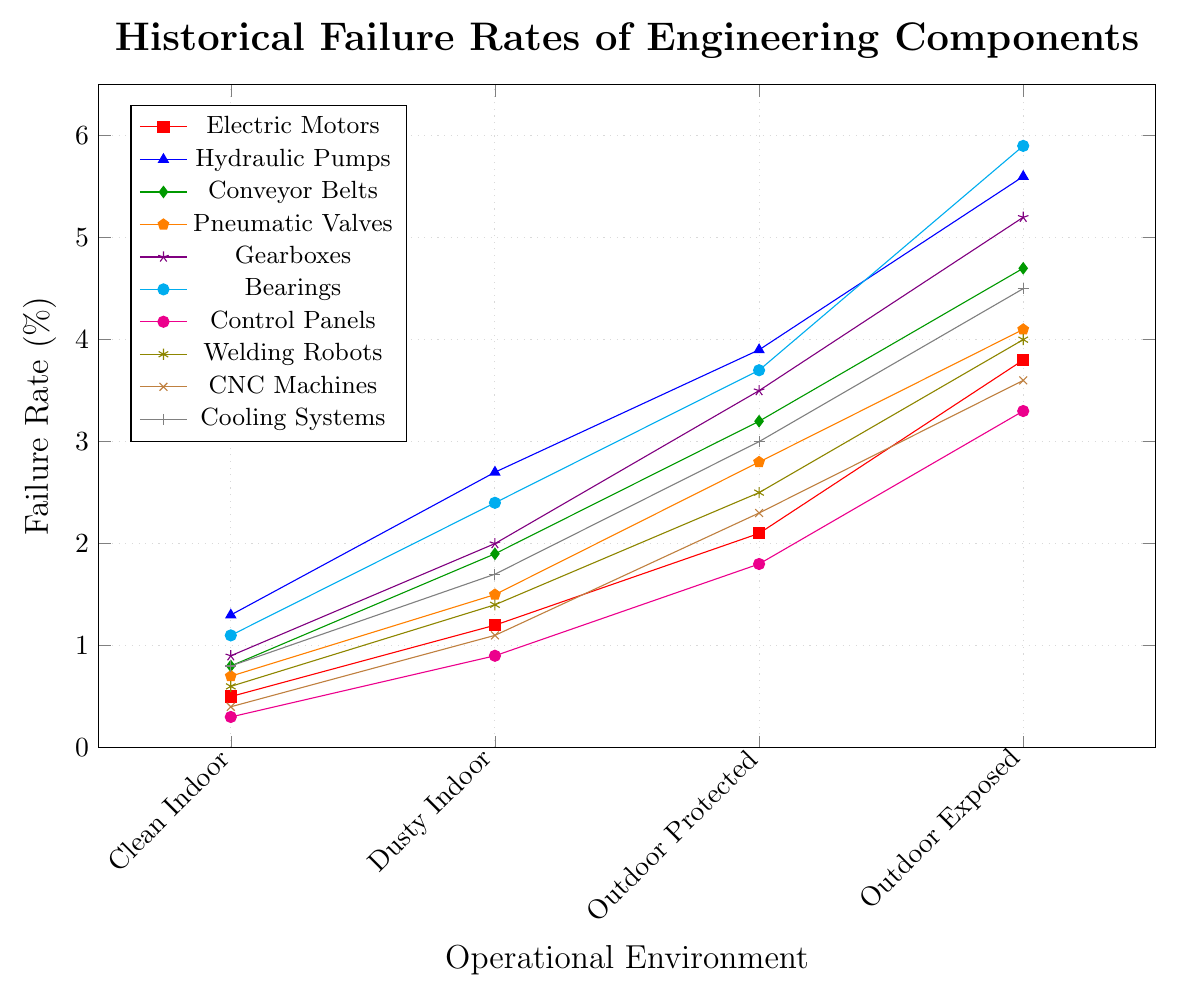Which component has the highest failure rate in the Outdoor Exposed environment? The highest failure rate in the Outdoor Exposed environment corresponds to the highest point on the graph for that condition, which is the Bearings at 5.9%.
Answer: Bearings Which component shows the lowest failure rate across all environments? To determine this, look for the lowest point across all environments. The lowest failure rate is for Control Panels in Clean Indoor environments at 0.3%.
Answer: Control Panels How does the failure rate of Conveyor Belts in Dusty Indoor environments compare to Electric Motors in the same environment? Compare the heights of the lines for Conveyor Belts and Electric Motors at the Dusty Indoor data point. Conveyor Belts have a failure rate of 1.9%, while Electric Motors have 1.2%.
Answer: Conveyor Belts have a higher rate What is the average failure rate of Cooling Systems across all environments? To calculate this, sum the failure rates for Cooling Systems across all environments (0.8 + 1.7 + 3.0 + 4.5 = 10) and divide by 4. The average is 10/4 = 2.5%.
Answer: 2.5% Which two components have a failure rate of exactly 4.0% in any environment? Find the lines intersecting the 4.0% mark on the vertical axis. Welding Robots and Electric Motors both reach 4.0% in Outdoor Exposed environments.
Answer: Welding Robots and Electric Motors In which environment is the difference between the failure rates of Bearings and Control Panels the greatest? Calculate the differences between Bearings and Control Panels in each environment: 
- Clean Indoor: 1.1 - 0.3 = 0.8
- Dusty Indoor: 2.4 - 0.9 = 1.5
- Outdoor Protected: 3.7 - 1.8 = 1.9
- Outdoor Exposed: 5.9 - 3.3 = 2.6
The greatest difference is in Outdoor Exposed (2.6).
Answer: Outdoor Exposed What is the sum of failure rates for Electric Motors and CNC Machines in Outdoor Protected environments? Add the failure rates for Electric Motors and CNC Machines in Outdoor Protected environments (2.1 + 2.3). The sum is 4.4%.
Answer: 4.4% Which component has the most consistent (smallest range) failure rate across the different environments? Calculate the range (max - min) of each component:
- Electric Motors: 3.8 - 0.5 = 3.3
- Hydraulic Pumps: 5.6 - 1.3 = 4.3
- Conveyor Belts: 4.7 - 0.8 = 3.9
- Pneumatic Valves: 4.1 - 0.7 = 3.4
- Gearboxes: 5.2 - 0.9 = 4.3
- Bearings: 5.9 - 1.1 = 4.8
- Control Panels: 3.3 - 0.3 = 3.0
- Welding Robots: 4.0 - 0.6 = 3.4
- CNC Machines: 3.6 - 0.4 = 3.2
- Cooling Systems: 4.5 - 0.8 = 3.7
Control Panels have the smallest range (3.0).
Answer: Control Panels What is the median failure rate for Hydraulic Pumps in all environments? Arrange the failure rates of Hydraulic Pumps in ascending order (1.3, 2.7, 3.9, 5.6). The median is the average of the two middle numbers (2.7 and 3.9), which is (2.7 + 3.9) / 2 = 3.3%.
Answer: 3.3% 